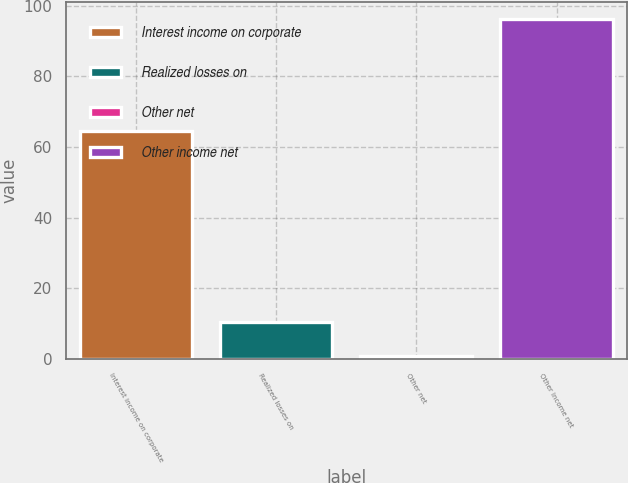Convert chart. <chart><loc_0><loc_0><loc_500><loc_500><bar_chart><fcel>Interest income on corporate<fcel>Realized losses on<fcel>Other net<fcel>Other income net<nl><fcel>64.5<fcel>10.43<fcel>0.9<fcel>96.2<nl></chart> 